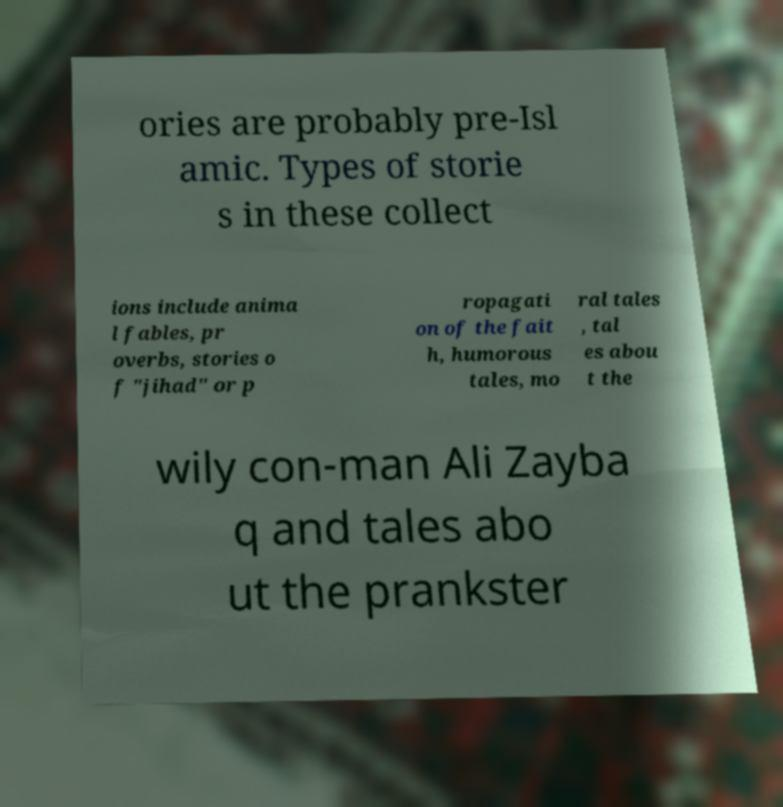I need the written content from this picture converted into text. Can you do that? ories are probably pre-Isl amic. Types of storie s in these collect ions include anima l fables, pr overbs, stories o f "jihad" or p ropagati on of the fait h, humorous tales, mo ral tales , tal es abou t the wily con-man Ali Zayba q and tales abo ut the prankster 